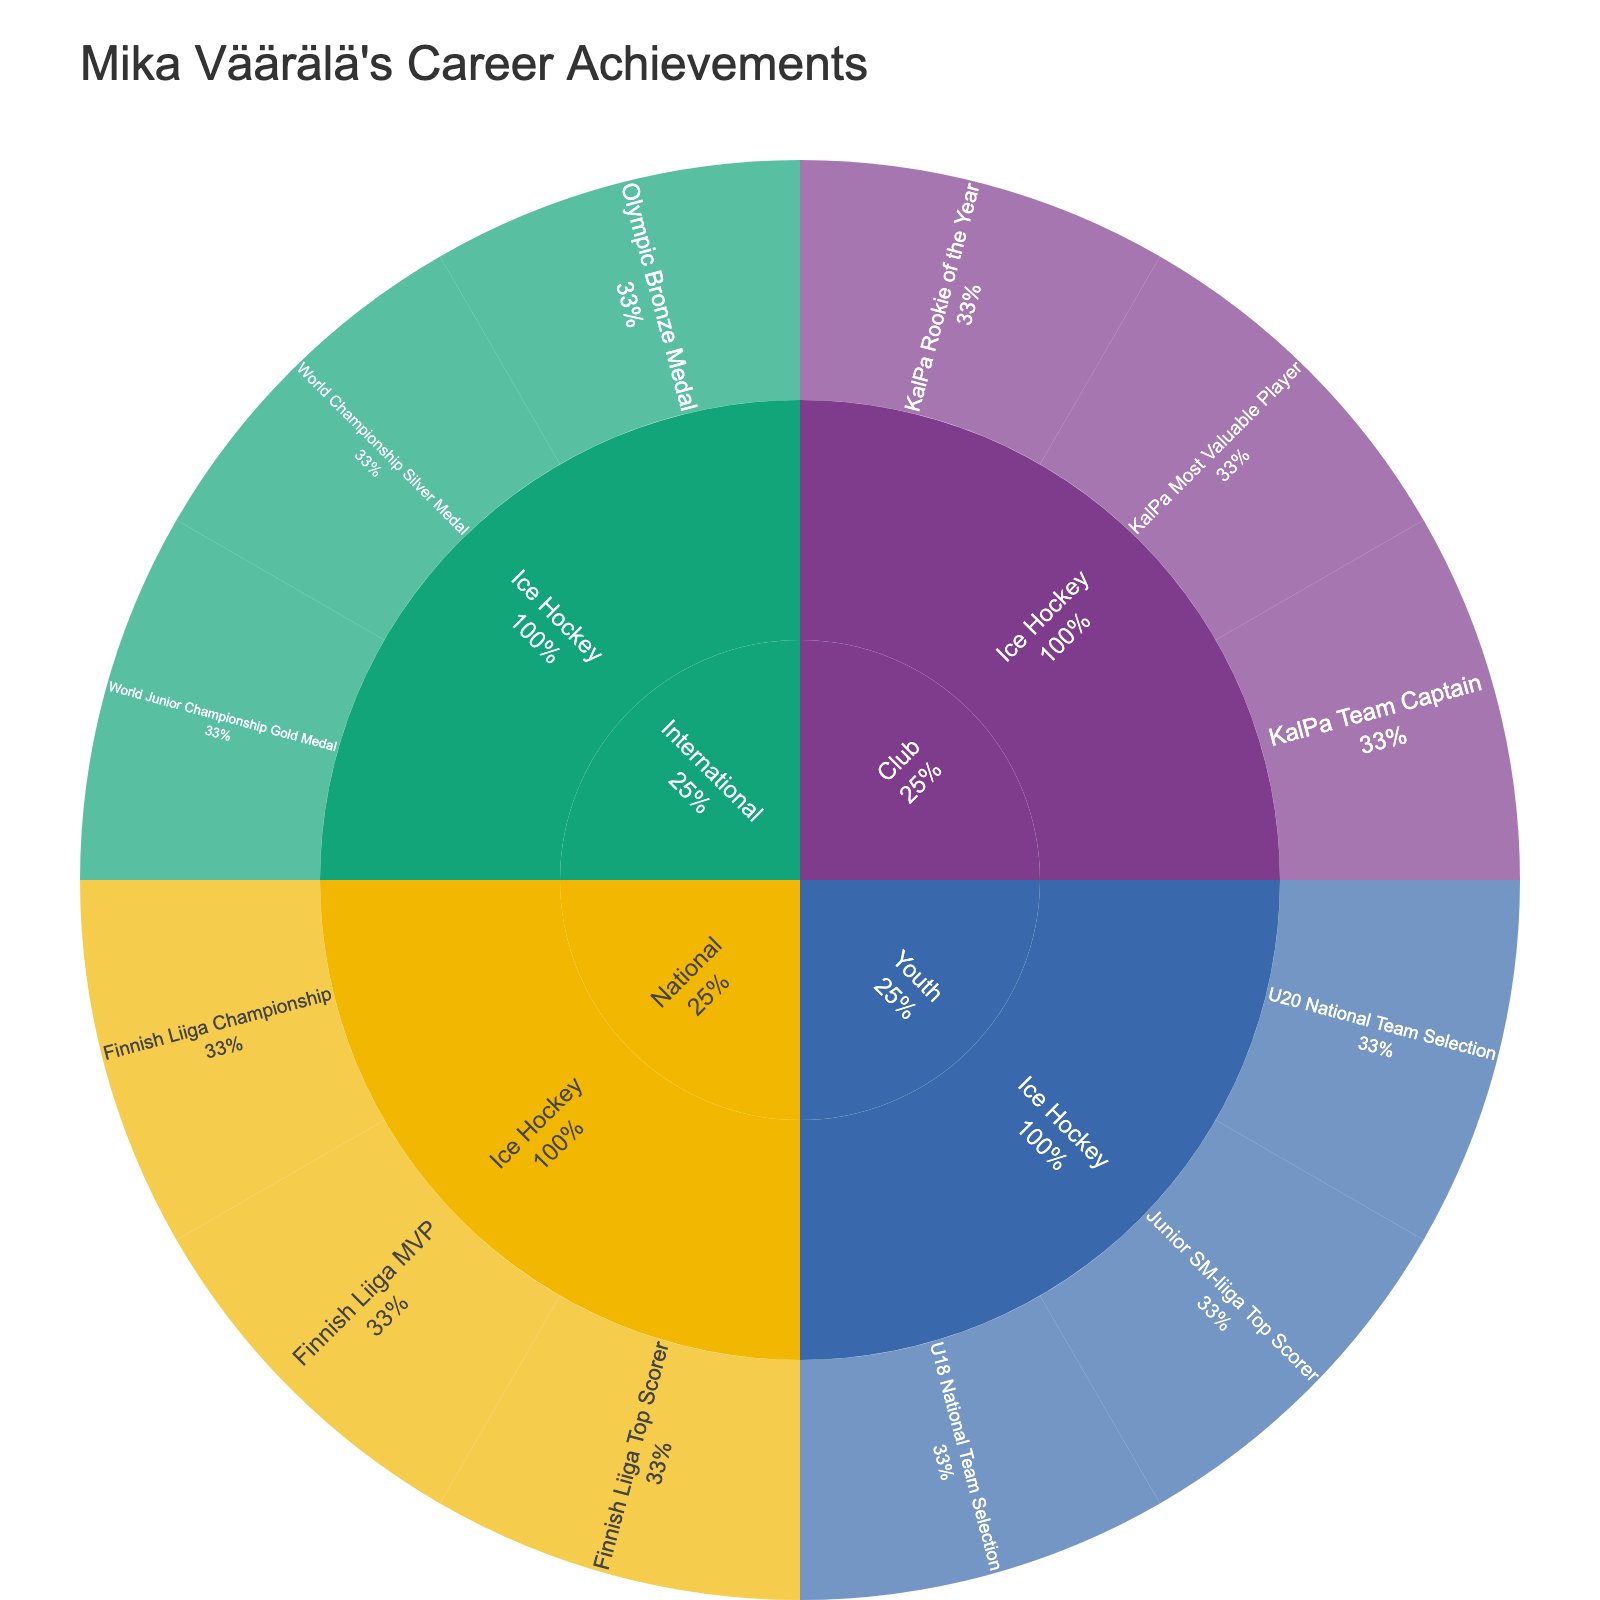What is the title of the Sunburst Plot? The title of the chart is usually prominently displayed at the top. In this chart, it reads "Mika Väärälä's Career Achievements".
Answer: Mika Väärälä's Career Achievements How many disciplines are covered in Mika Väärälä's career achievements? Looking into the levels of the chart, we can see that "Ice Hockey" is the only discipline highlighted.
Answer: One Which competition level has the most disciplines listed? All the nodes in the chart lead to the same discipline: Ice Hockey. Therefore, every competition level has the same number of disciplines.
Answer: All levels have the same number What international achievement is highlighted in the figure? By referring to the International level, we can identify three achievements under Ice Hockey: World Junior Championship Gold Medal, World Championship Silver Medal, and Olympic Bronze Medal.
Answer: World Junior Championship Gold Medal, World Championship Silver Medal, Olympic Bronze Medal How many achievements are listed under the National level? In the chart, the National level splits into Ice Hockey with three achievements: Finnish Liiga Championship, Finnish Liiga Top Scorer, and Finnish Liiga MVP. Summing these gives us three achievements.
Answer: Three Which competition level has fewer achievements, Club or Youth? By counting the leaves in the Sunburst Plot, Club level has three achievements, and Youth level has three as well. Since they have the same number, neither has fewer achievements.
Answer: Both have the same In the context of achievements specifically in the International level, which medal type appears most frequently? Under the International level, the medals are listed as Gold (World Junior Championship), Silver (World Championship), and Bronze (Olympic). Since each type is listed once, they all appear equally.
Answer: All appear equally What is the respective ratio of national to club level achievements? National level has three achievements (Finnish Liiga Championship, Top Scorer, MVP) and the Club level also has three achievements (KalPa Team Captain, Rookie of the Year, Most Valuable Player). The ratio hence is 3:3 or simplified, 1:1.
Answer: 1:1 Which achievement at the Youth level indicates a team selection? Under the Youth level and Ice Hockey discipline, two achievements mention team selection: U18 National Team Selection and U20 National Team Selection.
Answer: U18 National Team Selection, U20 National Team Selection What percentage of Mika Väärälä's career achievements are at the Club level? To find this, we count the number of total achievements which is twelve. Three out of these are at the club level (KalPa Team Captain, Rookie of the Year, Most Valuable Player). Calculating the percentage: (3/12) * 100 = 25%.
Answer: 25% 